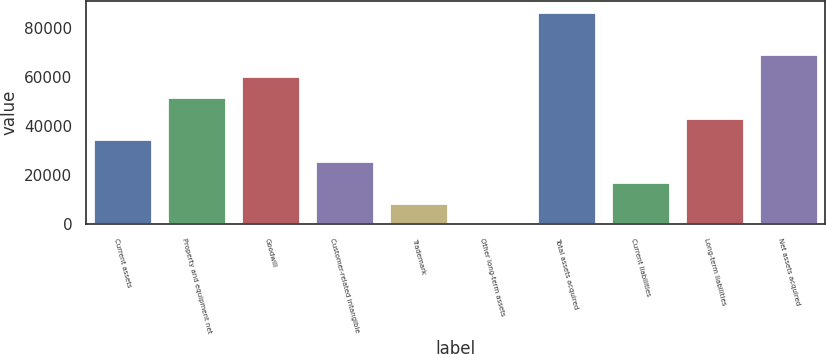Convert chart. <chart><loc_0><loc_0><loc_500><loc_500><bar_chart><fcel>Current assets<fcel>Property and equipment net<fcel>Goodwill<fcel>Customer-related intangible<fcel>Trademark<fcel>Other long-term assets<fcel>Total assets acquired<fcel>Current liabilities<fcel>Long-term liabilities<fcel>Net assets acquired<nl><fcel>34566.6<fcel>51844.4<fcel>60483.3<fcel>25927.7<fcel>8649.9<fcel>11<fcel>86400<fcel>17288.8<fcel>43205.5<fcel>69122.2<nl></chart> 